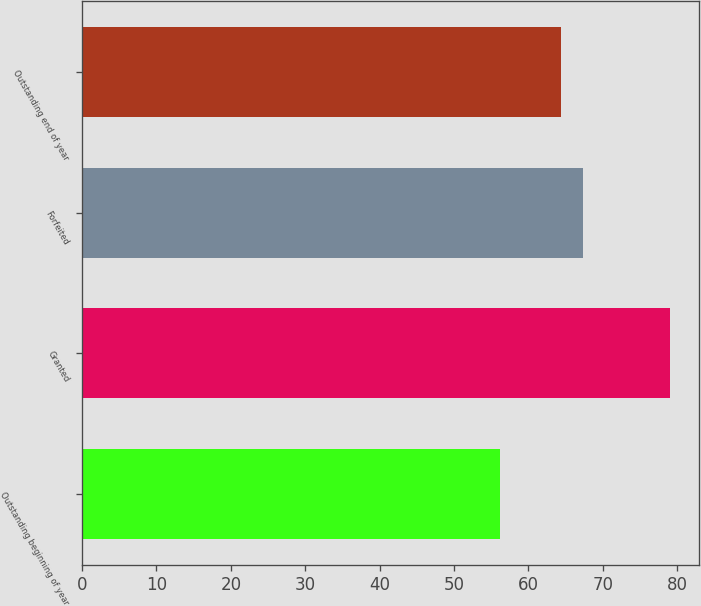Convert chart to OTSL. <chart><loc_0><loc_0><loc_500><loc_500><bar_chart><fcel>Outstanding beginning of year<fcel>Granted<fcel>Forfeited<fcel>Outstanding end of year<nl><fcel>56.17<fcel>79<fcel>67.3<fcel>64.43<nl></chart> 